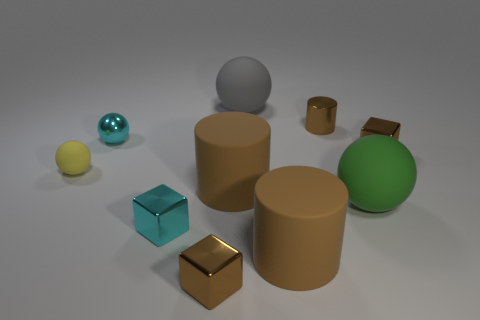How many brown cylinders must be subtracted to get 1 brown cylinders? 2 Subtract all green rubber spheres. How many spheres are left? 3 Subtract all yellow cylinders. How many brown blocks are left? 2 Subtract all cyan balls. How many balls are left? 3 Subtract 1 cylinders. How many cylinders are left? 2 Subtract 0 blue spheres. How many objects are left? 10 Subtract all cubes. How many objects are left? 7 Subtract all green blocks. Subtract all purple cylinders. How many blocks are left? 3 Subtract all gray rubber things. Subtract all tiny brown cylinders. How many objects are left? 8 Add 6 large objects. How many large objects are left? 10 